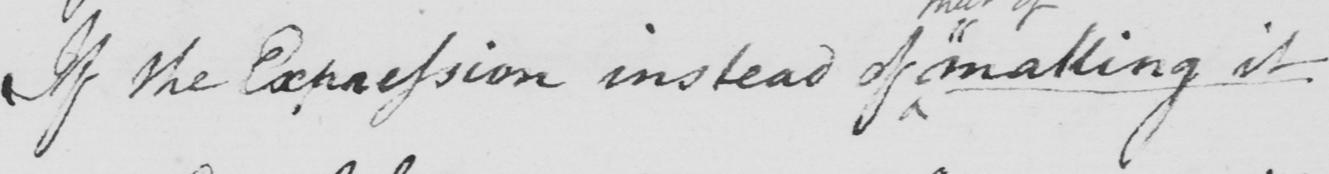Can you tell me what this handwritten text says? If the Expression instead of  " making it 